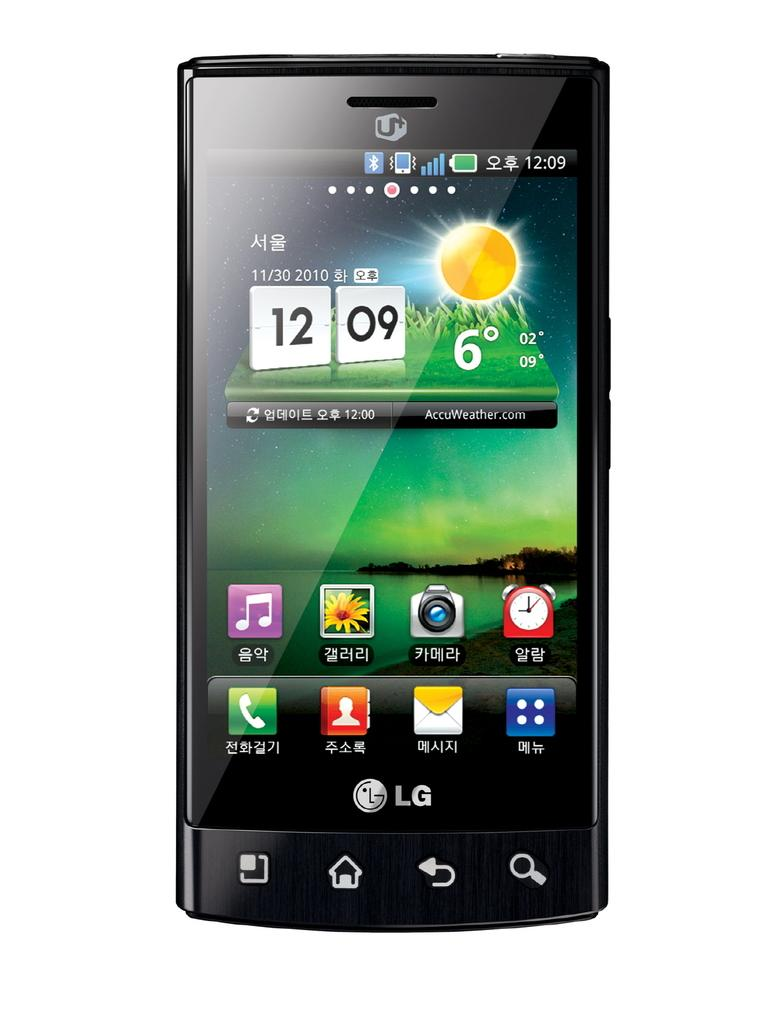<image>
Present a compact description of the photo's key features. a black LG cell phone with a weather app as the start up screen 